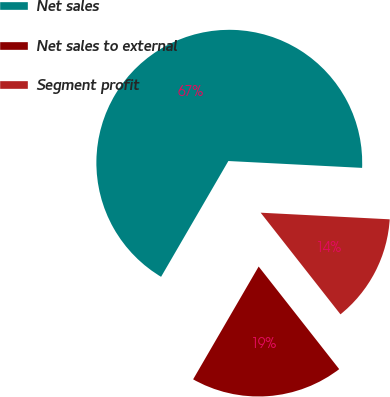<chart> <loc_0><loc_0><loc_500><loc_500><pie_chart><fcel>Net sales<fcel>Net sales to external<fcel>Segment profit<nl><fcel>67.44%<fcel>18.97%<fcel>13.59%<nl></chart> 